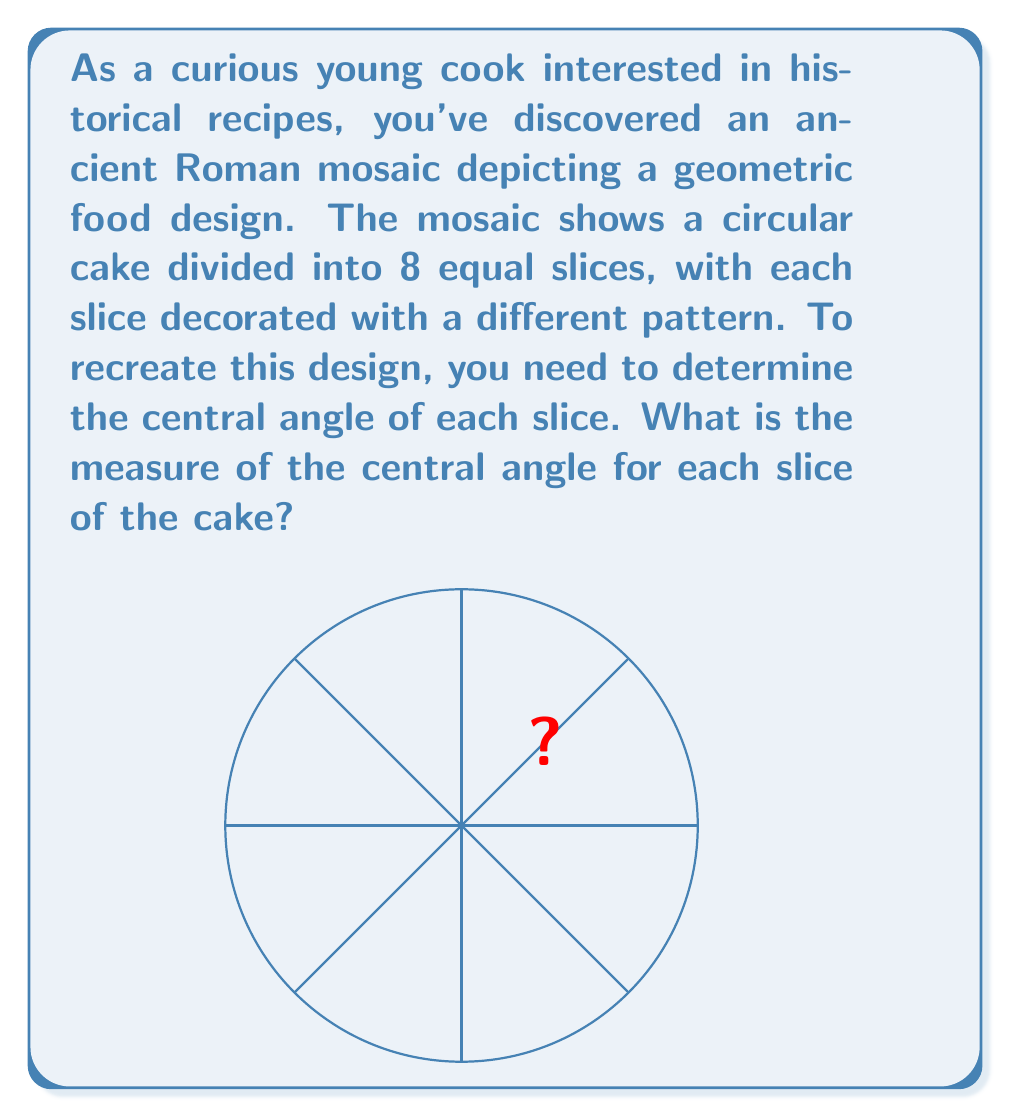Provide a solution to this math problem. To solve this problem, we need to understand that a full circle contains 360°. Since the cake is divided into 8 equal slices, we need to divide the total degrees in a circle by the number of slices.

Step 1: Identify the total degrees in a circle
$$\text{Total degrees} = 360°$$

Step 2: Count the number of slices
$$\text{Number of slices} = 8$$

Step 3: Calculate the central angle for each slice
$$\text{Central angle} = \frac{\text{Total degrees}}{\text{Number of slices}}$$
$$\text{Central angle} = \frac{360°}{8}$$
$$\text{Central angle} = 45°$$

Therefore, each slice of the cake has a central angle of 45°.

This knowledge allows you to recreate the geometric design accurately, ensuring that each slice of your historical Roman cake recreation has the correct proportions.
Answer: The measure of the central angle for each slice of the cake is 45°. 